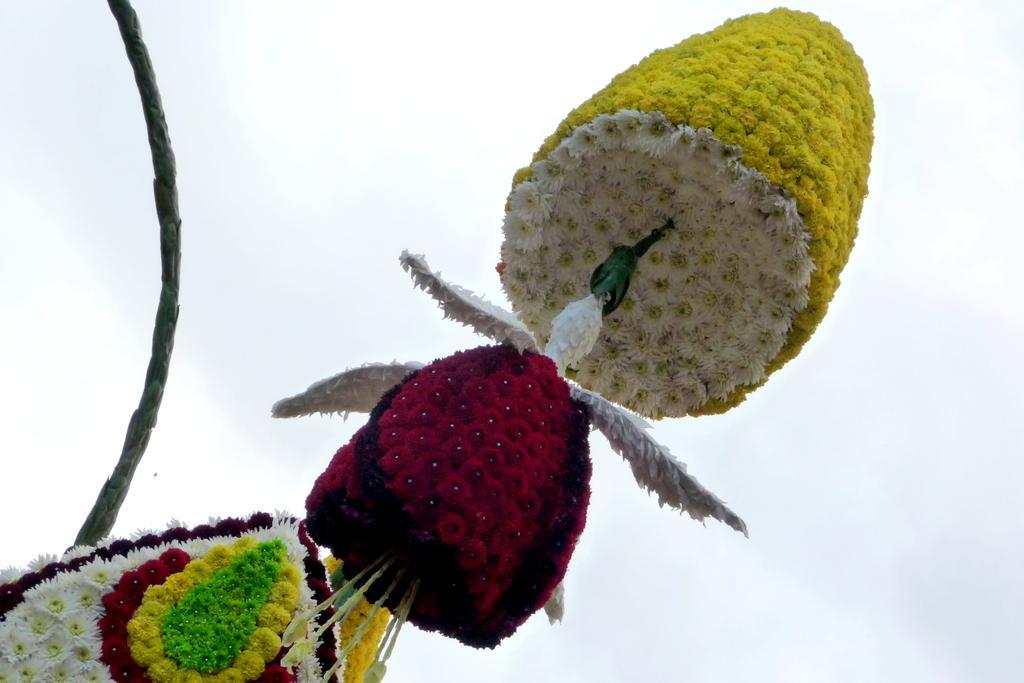In one or two sentences, can you explain what this image depicts? In this image I see flowers which are of white, yellow, green and red in color and in the background I see the clear sky and I see the green color thing over here. 